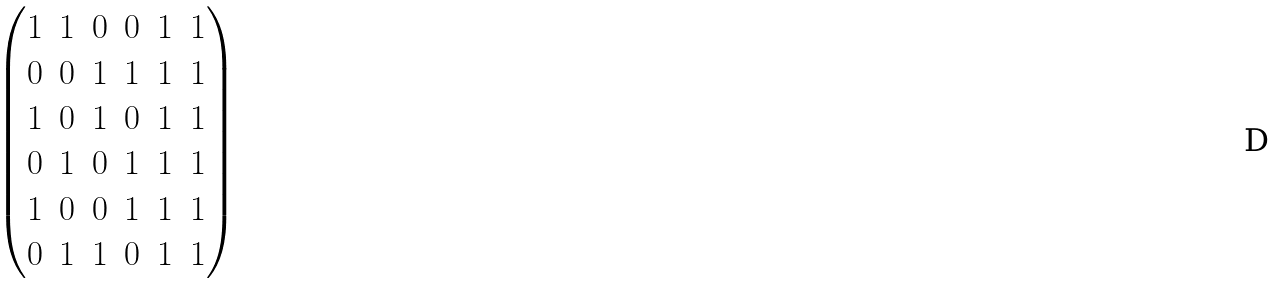Convert formula to latex. <formula><loc_0><loc_0><loc_500><loc_500>\begin{pmatrix} 1 & 1 & 0 & 0 & 1 & 1 \\ 0 & 0 & 1 & 1 & 1 & 1 \\ 1 & 0 & 1 & 0 & 1 & 1 \\ 0 & 1 & 0 & 1 & 1 & 1 \\ 1 & 0 & 0 & 1 & 1 & 1 \\ 0 & 1 & 1 & 0 & 1 & 1 \end{pmatrix}</formula> 